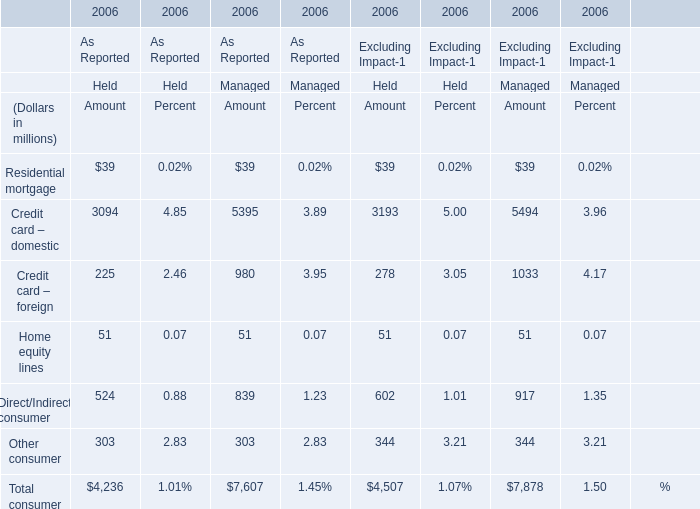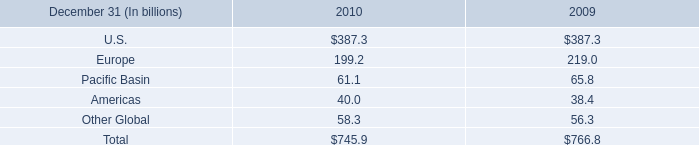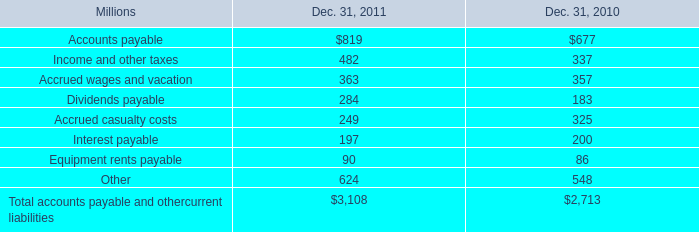What's the sum of consumer As Reported in 2006? (in dollars in millions) 
Computations: (4236 + 7607)
Answer: 11843.0. 